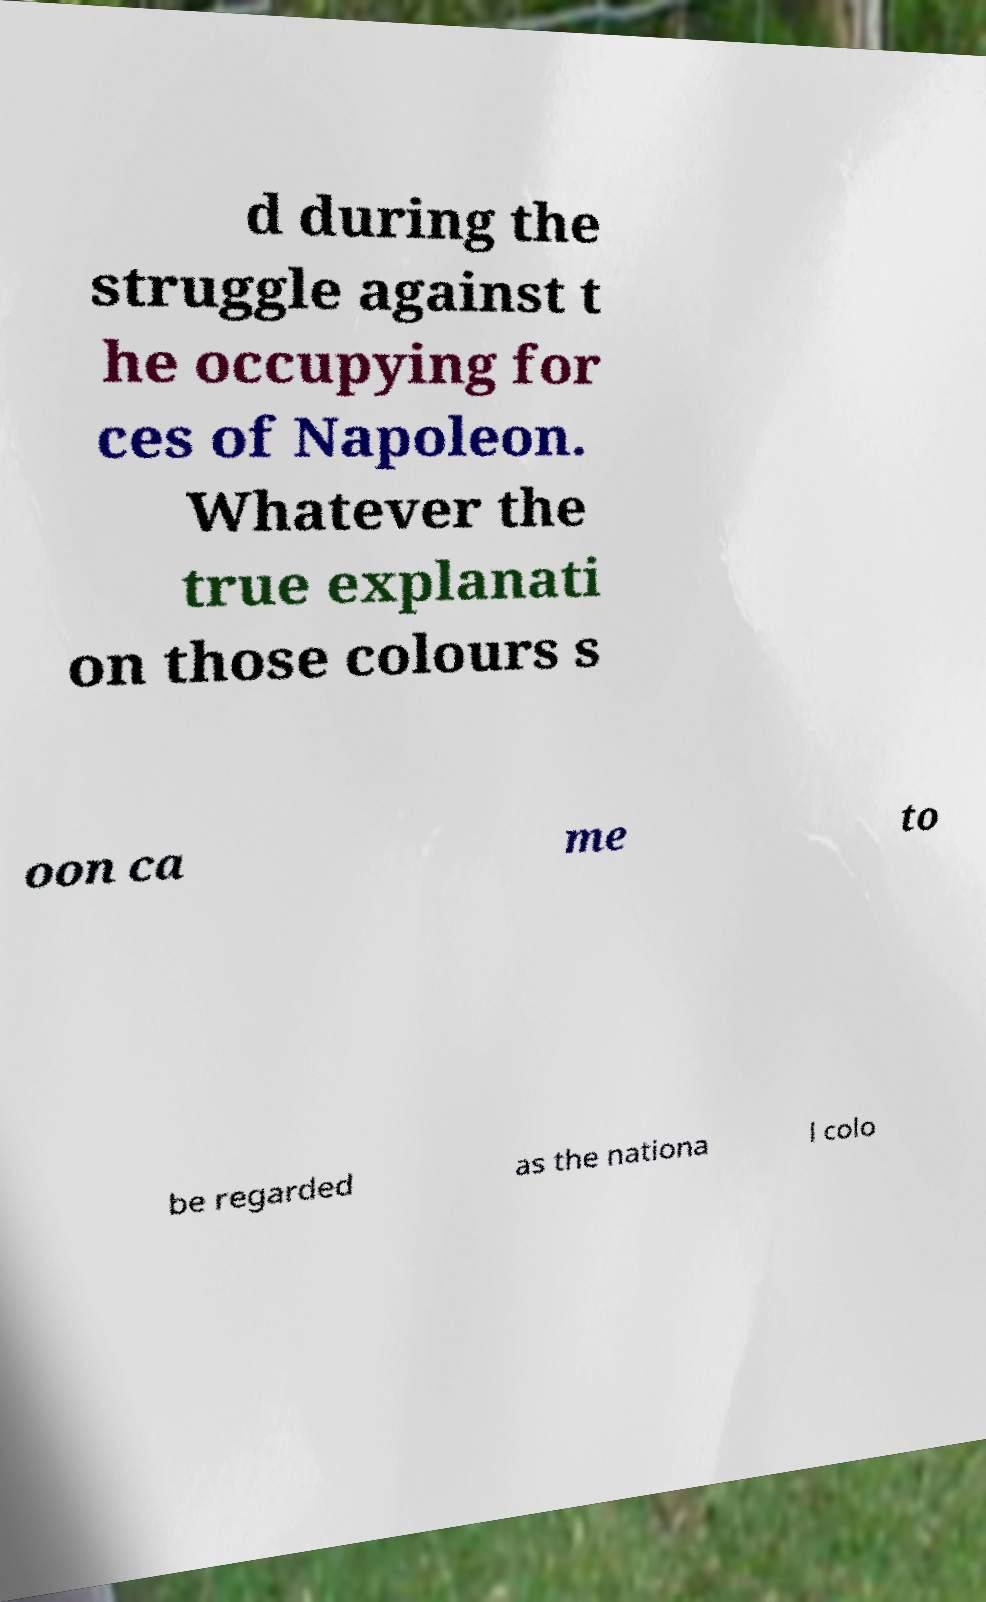Can you accurately transcribe the text from the provided image for me? d during the struggle against t he occupying for ces of Napoleon. Whatever the true explanati on those colours s oon ca me to be regarded as the nationa l colo 